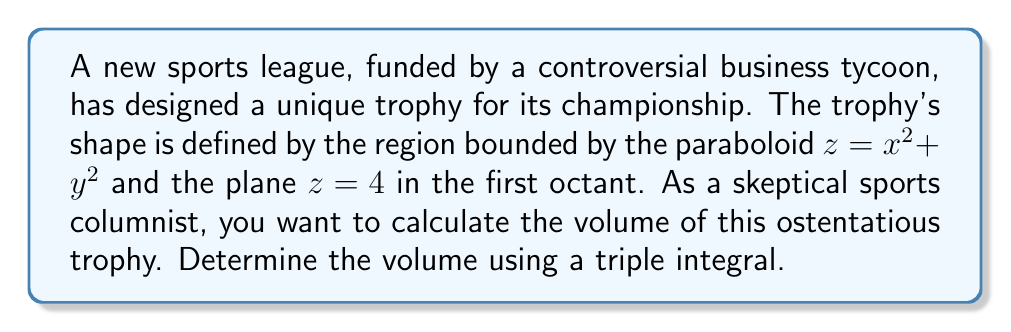Show me your answer to this math problem. To calculate the volume of the trophy, we need to set up and evaluate a triple integral. Let's approach this step-by-step:

1) The region is bounded by $z = x^2 + y^2$ from below and $z = 4$ from above, in the first octant (where x, y, and z are all non-negative).

2) We can set up the triple integral in cylindrical coordinates:
   $$ V = \int\int\int r \, dz \, dr \, d\theta $$

3) The limits of integration:
   - $\theta$ goes from 0 to $\pi/2$ (quarter circle in the xy-plane)
   - $r$ goes from 0 to 2 (where the paraboloid intersects the plane z = 4)
   - $z$ goes from $r^2$ to 4

4) Our integral becomes:
   $$ V = \int_0^{\pi/2} \int_0^2 \int_{r^2}^4 r \, dz \, dr \, d\theta $$

5) Integrate with respect to z:
   $$ V = \int_0^{\pi/2} \int_0^2 r(4-r^2) \, dr \, d\theta $$

6) Integrate with respect to r:
   $$ V = \int_0^{\pi/2} \left[2r^2 - \frac{r^4}{4}\right]_0^2 \, d\theta $$
   $$ V = \int_0^{\pi/2} \left(8 - 4\right) \, d\theta = 4 \int_0^{\pi/2} \, d\theta $$

7) Finally, integrate with respect to θ:
   $$ V = 4 \cdot \frac{\pi}{2} = 2\pi $$

Therefore, the volume of the trophy is $2\pi$ cubic units.
Answer: $2\pi$ cubic units 